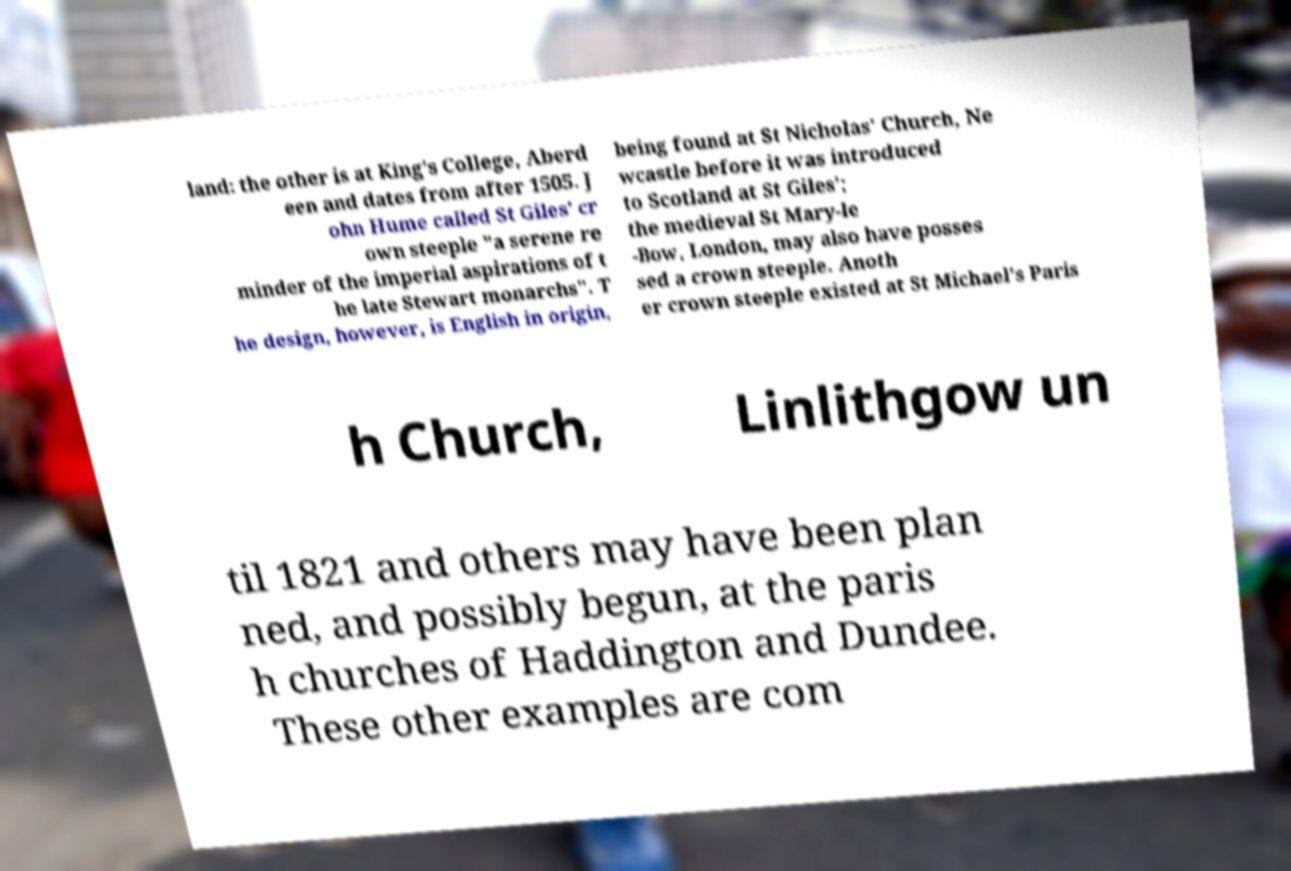Please read and relay the text visible in this image. What does it say? land: the other is at King's College, Aberd een and dates from after 1505. J ohn Hume called St Giles' cr own steeple "a serene re minder of the imperial aspirations of t he late Stewart monarchs". T he design, however, is English in origin, being found at St Nicholas' Church, Ne wcastle before it was introduced to Scotland at St Giles'; the medieval St Mary-le -Bow, London, may also have posses sed a crown steeple. Anoth er crown steeple existed at St Michael's Paris h Church, Linlithgow un til 1821 and others may have been plan ned, and possibly begun, at the paris h churches of Haddington and Dundee. These other examples are com 